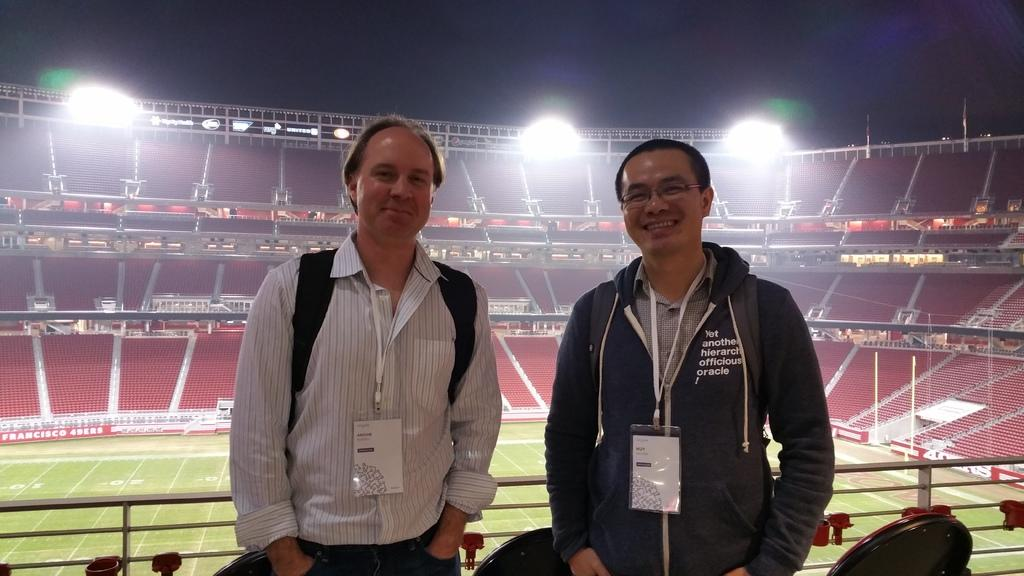How many people are in the image? There are two persons in the image. What are the persons wearing that can be seen in the image? The persons are wearing ID cards. What is the facial expression of the persons in the image? The persons are smiling. What can be seen in the background of the image? There is a stadium and a playground in the background of the image. What is visible in the image that provides illumination? Lights are visible in the image. What type of cattle can be seen grazing on the sheet in the image? There is no cattle or sheet present in the image. What type of exchange is taking place between the two persons in the image? There is no exchange taking place between the two persons in the image; they are simply wearing ID cards and smiling. 